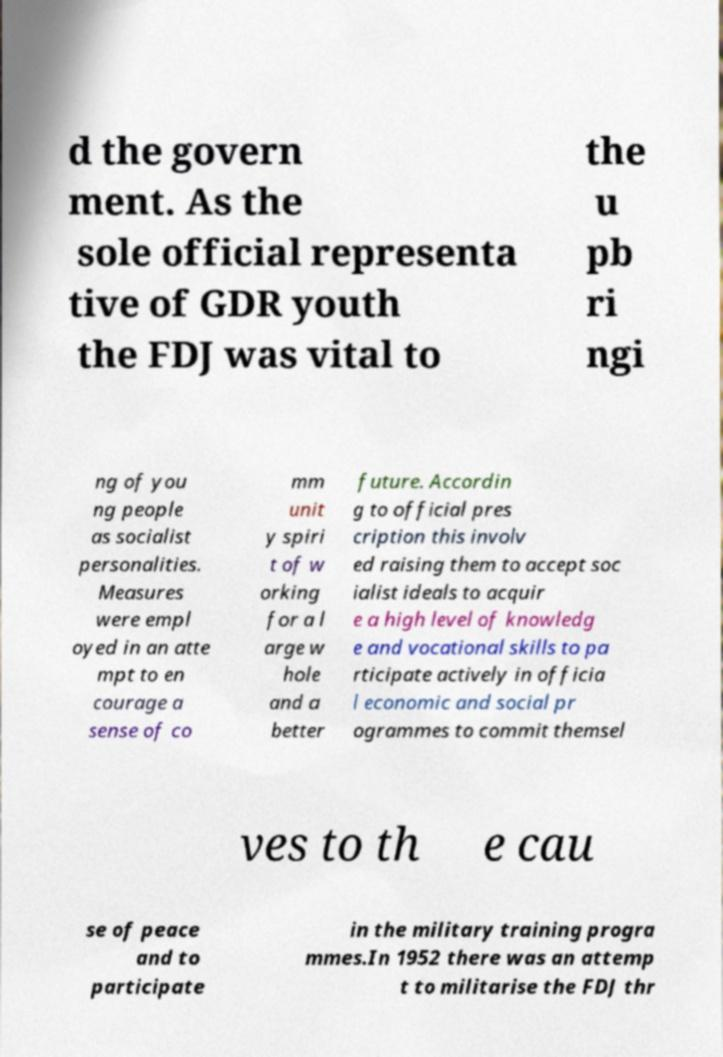Could you assist in decoding the text presented in this image and type it out clearly? d the govern ment. As the sole official representa tive of GDR youth the FDJ was vital to the u pb ri ngi ng of you ng people as socialist personalities. Measures were empl oyed in an atte mpt to en courage a sense of co mm unit y spiri t of w orking for a l arge w hole and a better future. Accordin g to official pres cription this involv ed raising them to accept soc ialist ideals to acquir e a high level of knowledg e and vocational skills to pa rticipate actively in officia l economic and social pr ogrammes to commit themsel ves to th e cau se of peace and to participate in the military training progra mmes.In 1952 there was an attemp t to militarise the FDJ thr 